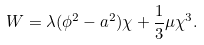<formula> <loc_0><loc_0><loc_500><loc_500>W = \lambda ( \phi ^ { 2 } - a ^ { 2 } ) \chi + \frac { 1 } { 3 } \mu \chi ^ { 3 } .</formula> 